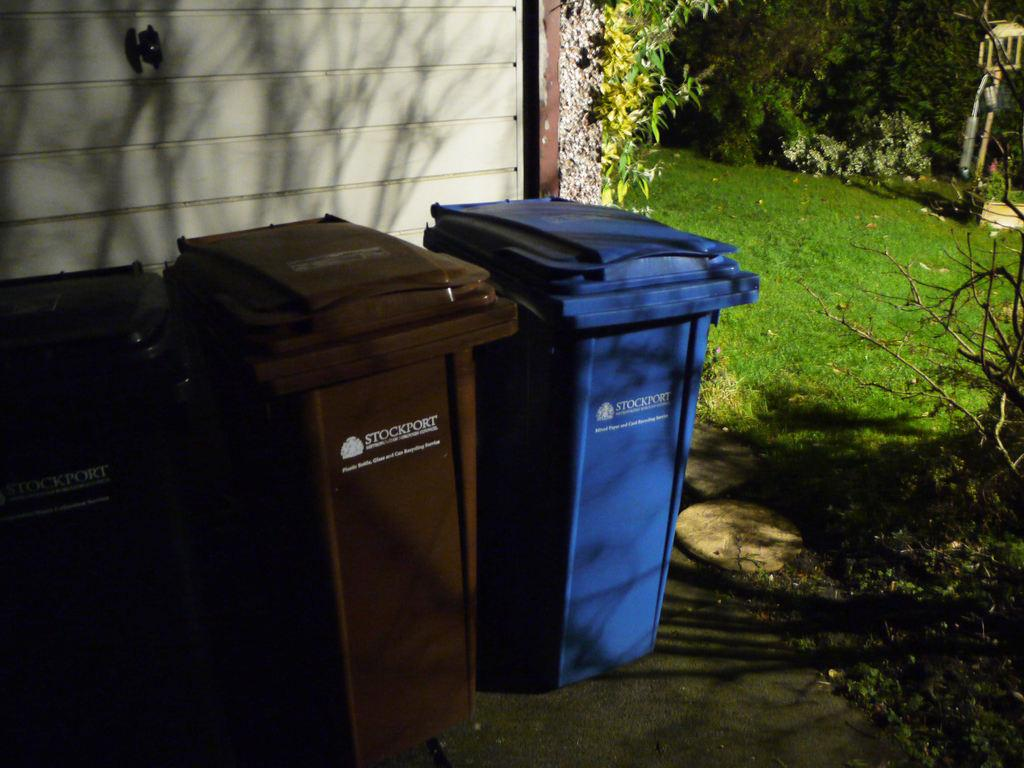What is the main subject in the center of the image? There are dustbins in the center of the image. What can be seen in the background of the image? There is a wall, plants, grass, flowers, and objects in the background of the image. What type of surface is visible at the bottom of the image? There is a walkway at the bottom of the image. How many lizards are crawling on the wall in the image? There are no lizards visible in the image. What shape is the mother in the image? There is no mother present in the image. 